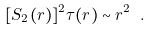Convert formula to latex. <formula><loc_0><loc_0><loc_500><loc_500>[ S _ { 2 } ( r ) ] ^ { 2 } \tau ( r ) \sim r ^ { 2 } \ .</formula> 